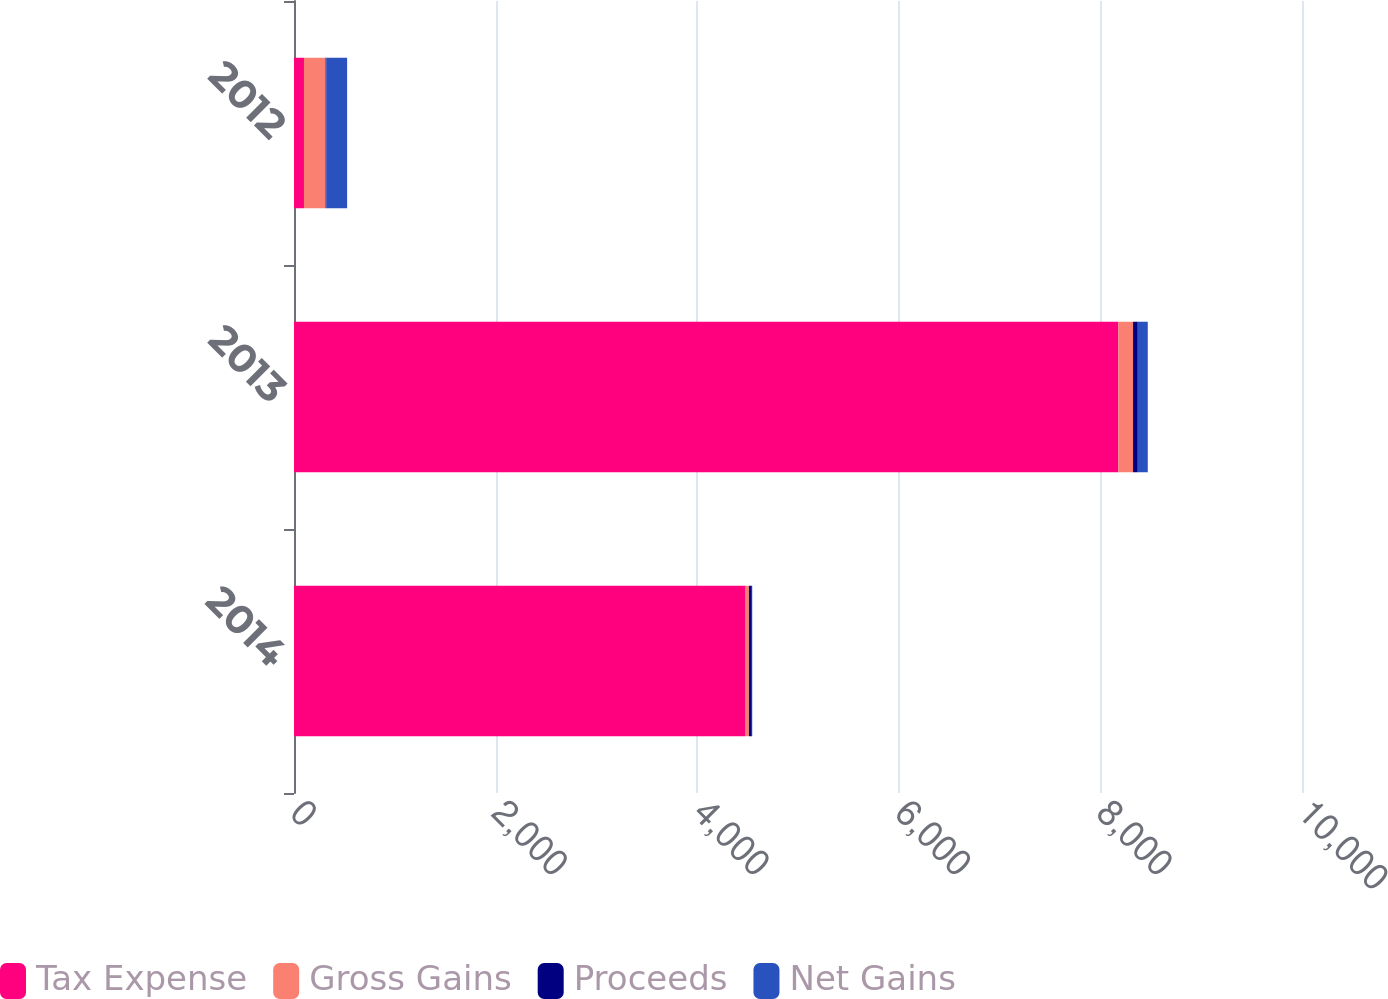<chart> <loc_0><loc_0><loc_500><loc_500><stacked_bar_chart><ecel><fcel>2014<fcel>2013<fcel>2012<nl><fcel>Tax Expense<fcel>4480<fcel>8178<fcel>99<nl><fcel>Gross Gains<fcel>33<fcel>146<fcel>214<nl><fcel>Proceeds<fcel>29<fcel>47<fcel>10<nl><fcel>Net Gains<fcel>4<fcel>99<fcel>204<nl></chart> 